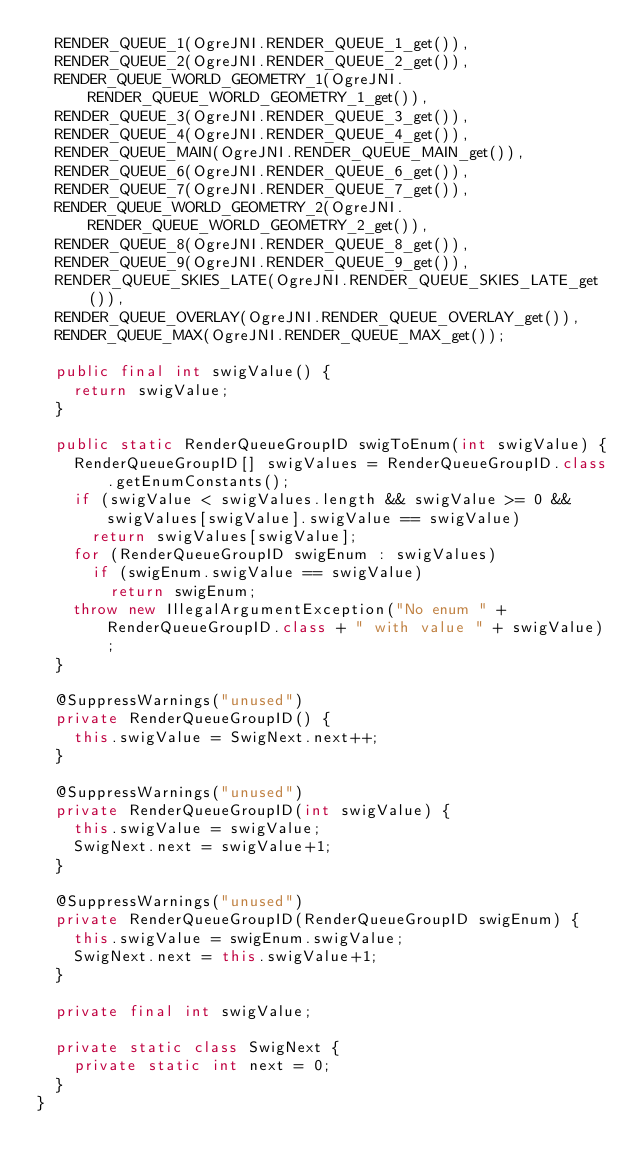Convert code to text. <code><loc_0><loc_0><loc_500><loc_500><_Java_>  RENDER_QUEUE_1(OgreJNI.RENDER_QUEUE_1_get()),
  RENDER_QUEUE_2(OgreJNI.RENDER_QUEUE_2_get()),
  RENDER_QUEUE_WORLD_GEOMETRY_1(OgreJNI.RENDER_QUEUE_WORLD_GEOMETRY_1_get()),
  RENDER_QUEUE_3(OgreJNI.RENDER_QUEUE_3_get()),
  RENDER_QUEUE_4(OgreJNI.RENDER_QUEUE_4_get()),
  RENDER_QUEUE_MAIN(OgreJNI.RENDER_QUEUE_MAIN_get()),
  RENDER_QUEUE_6(OgreJNI.RENDER_QUEUE_6_get()),
  RENDER_QUEUE_7(OgreJNI.RENDER_QUEUE_7_get()),
  RENDER_QUEUE_WORLD_GEOMETRY_2(OgreJNI.RENDER_QUEUE_WORLD_GEOMETRY_2_get()),
  RENDER_QUEUE_8(OgreJNI.RENDER_QUEUE_8_get()),
  RENDER_QUEUE_9(OgreJNI.RENDER_QUEUE_9_get()),
  RENDER_QUEUE_SKIES_LATE(OgreJNI.RENDER_QUEUE_SKIES_LATE_get()),
  RENDER_QUEUE_OVERLAY(OgreJNI.RENDER_QUEUE_OVERLAY_get()),
  RENDER_QUEUE_MAX(OgreJNI.RENDER_QUEUE_MAX_get());

  public final int swigValue() {
    return swigValue;
  }

  public static RenderQueueGroupID swigToEnum(int swigValue) {
    RenderQueueGroupID[] swigValues = RenderQueueGroupID.class.getEnumConstants();
    if (swigValue < swigValues.length && swigValue >= 0 && swigValues[swigValue].swigValue == swigValue)
      return swigValues[swigValue];
    for (RenderQueueGroupID swigEnum : swigValues)
      if (swigEnum.swigValue == swigValue)
        return swigEnum;
    throw new IllegalArgumentException("No enum " + RenderQueueGroupID.class + " with value " + swigValue);
  }

  @SuppressWarnings("unused")
  private RenderQueueGroupID() {
    this.swigValue = SwigNext.next++;
  }

  @SuppressWarnings("unused")
  private RenderQueueGroupID(int swigValue) {
    this.swigValue = swigValue;
    SwigNext.next = swigValue+1;
  }

  @SuppressWarnings("unused")
  private RenderQueueGroupID(RenderQueueGroupID swigEnum) {
    this.swigValue = swigEnum.swigValue;
    SwigNext.next = this.swigValue+1;
  }

  private final int swigValue;

  private static class SwigNext {
    private static int next = 0;
  }
}

</code> 